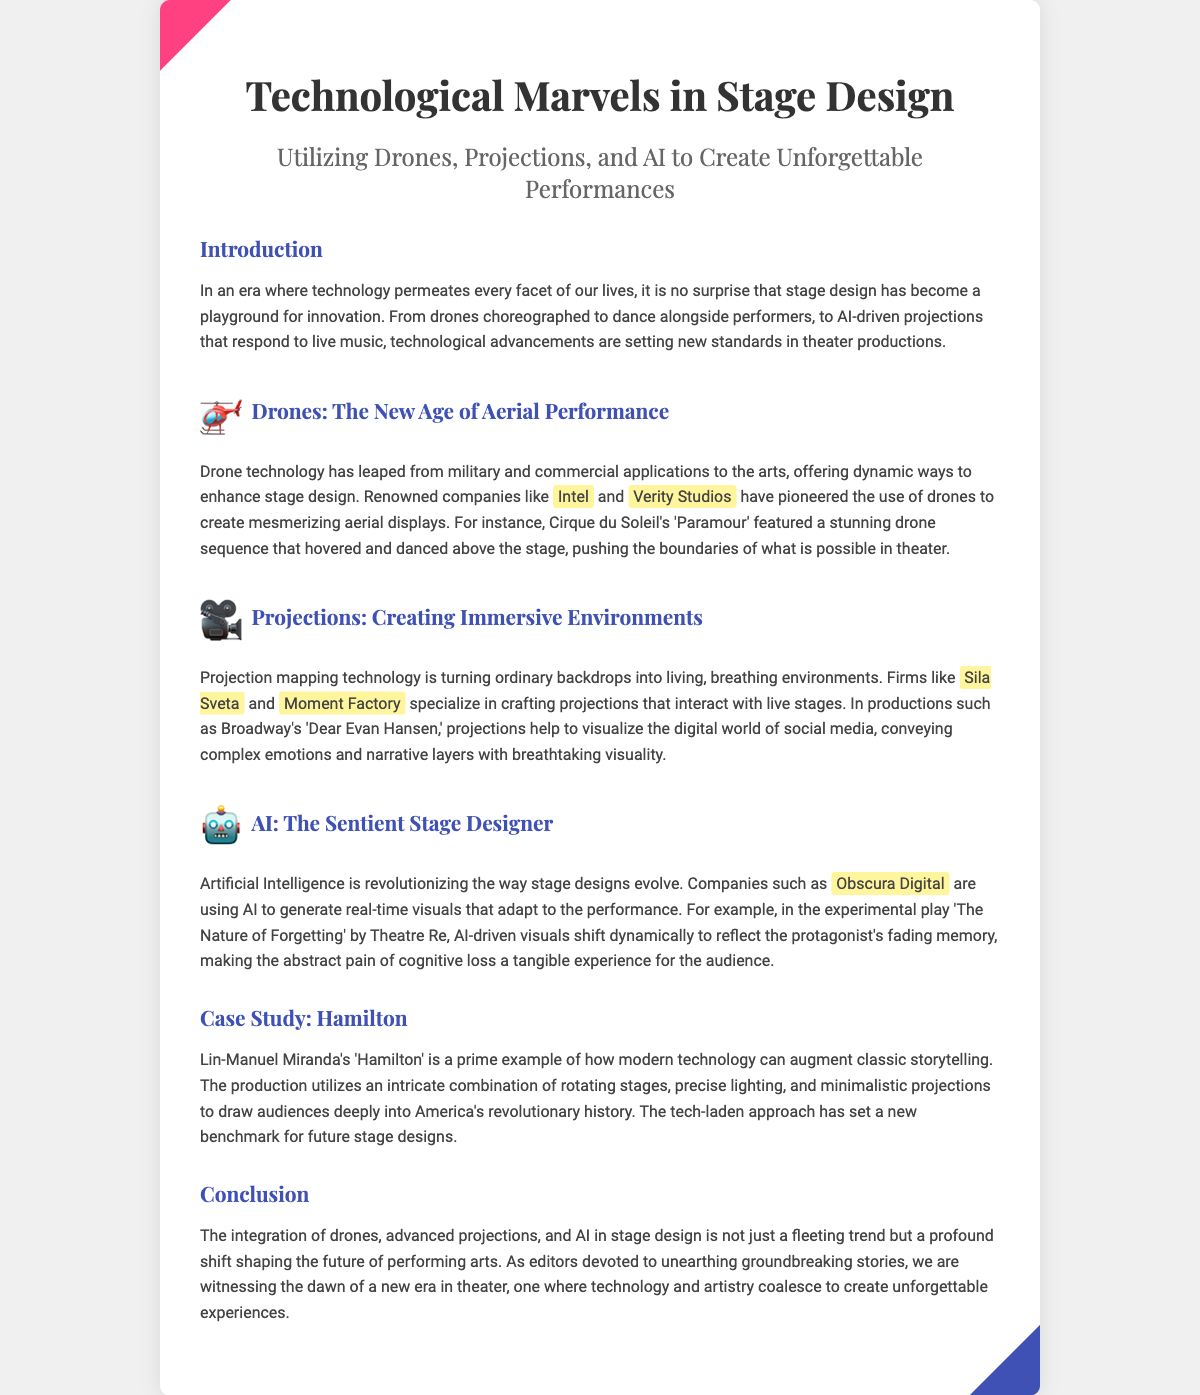What is the title of the document? The title of the document is found in the heading at the top, which states "Technological Marvels in Stage Design".
Answer: Technological Marvels in Stage Design Who are the companies mentioned that are involved in drone technology? The document lists two companies, Intel and Verity Studios, as pioneers in drone technology for stage design.
Answer: Intel and Verity Studios What technology is used to create immersive environments? The document specifies that projection mapping technology is utilized for creating immersive environments on stage.
Answer: Projection mapping In which production is AI driven visuals used? The document mentions the experimental play 'The Nature of Forgetting' by Theatre Re as an example of AI driven visuals.
Answer: The Nature of Forgetting Which renowned work exemplifies modern technology in theater? The document highlights Lin-Manuel Miranda's 'Hamilton' as a prime example of modern technology augmenting classic storytelling.
Answer: Hamilton What are the three technologies discussed in the document? The technologies mentioned are drones, projections, and AI, which are integrated into stage design.
Answer: Drones, projections, and AI How does AI enhance the audience's experience according to the document? The document states that AI generates real-time visuals that adapt to performances, enhancing the experiential aspect for the audience.
Answer: Real-time visuals What is the purpose of the document? The purpose of the document is to explore and highlight the integration of technology in stage design to create unforgettable performances.
Answer: Explore and highlight technology in stage design 